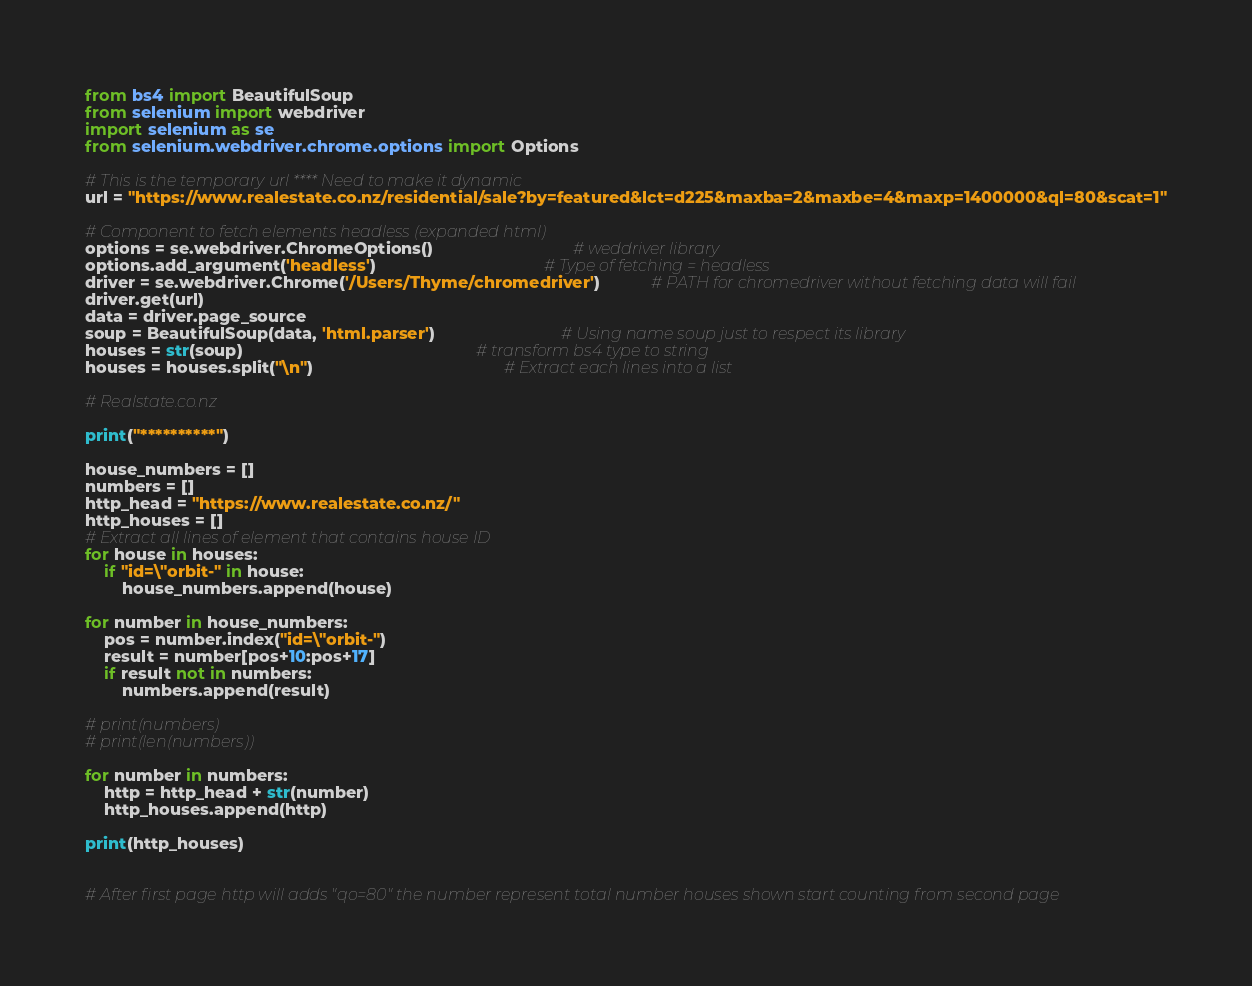<code> <loc_0><loc_0><loc_500><loc_500><_Python_>from bs4 import BeautifulSoup
from selenium import webdriver
import selenium as se
from selenium.webdriver.chrome.options import Options

# This is the temporary url **** Need to make it dynamic
url = "https://www.realestate.co.nz/residential/sale?by=featured&lct=d225&maxba=2&maxbe=4&maxp=1400000&ql=80&scat=1"

# Component to fetch elements headless (expanded html)
options = se.webdriver.ChromeOptions()                              # weddriver library
options.add_argument('headless')                                    # Type of fetching = headless
driver = se.webdriver.Chrome('/Users/Thyme/chromedriver')           # PATH for chromedriver without fetching data will fail
driver.get(url)
data = driver.page_source
soup = BeautifulSoup(data, 'html.parser')                           # Using name soup just to respect its library
houses = str(soup)                                                  # transform bs4 type to string
houses = houses.split("\n")                                         # Extract each lines into a list

# Realstate.co.nz

print("**********")

house_numbers = []
numbers = []
http_head = "https://www.realestate.co.nz/"
http_houses = []
# Extract all lines of element that contains house ID
for house in houses:
    if "id=\"orbit-" in house:
        house_numbers.append(house)

for number in house_numbers:
    pos = number.index("id=\"orbit-")
    result = number[pos+10:pos+17]
    if result not in numbers:
        numbers.append(result)

# print(numbers)
# print(len(numbers))

for number in numbers:
    http = http_head + str(number)
    http_houses.append(http)

print(http_houses)


# After first page http will adds "qo=80" the number represent total number houses shown start counting from second page</code> 